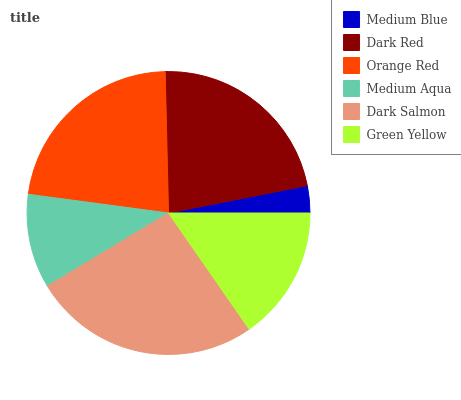Is Medium Blue the minimum?
Answer yes or no. Yes. Is Dark Salmon the maximum?
Answer yes or no. Yes. Is Dark Red the minimum?
Answer yes or no. No. Is Dark Red the maximum?
Answer yes or no. No. Is Dark Red greater than Medium Blue?
Answer yes or no. Yes. Is Medium Blue less than Dark Red?
Answer yes or no. Yes. Is Medium Blue greater than Dark Red?
Answer yes or no. No. Is Dark Red less than Medium Blue?
Answer yes or no. No. Is Dark Red the high median?
Answer yes or no. Yes. Is Green Yellow the low median?
Answer yes or no. Yes. Is Dark Salmon the high median?
Answer yes or no. No. Is Dark Salmon the low median?
Answer yes or no. No. 